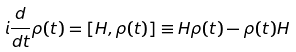Convert formula to latex. <formula><loc_0><loc_0><loc_500><loc_500>i \frac { d } { d t } { \rho } ( t ) = [ { H } , { \rho } ( t ) ] \equiv H { \rho } ( t ) - { \rho } ( t ) { H }</formula> 